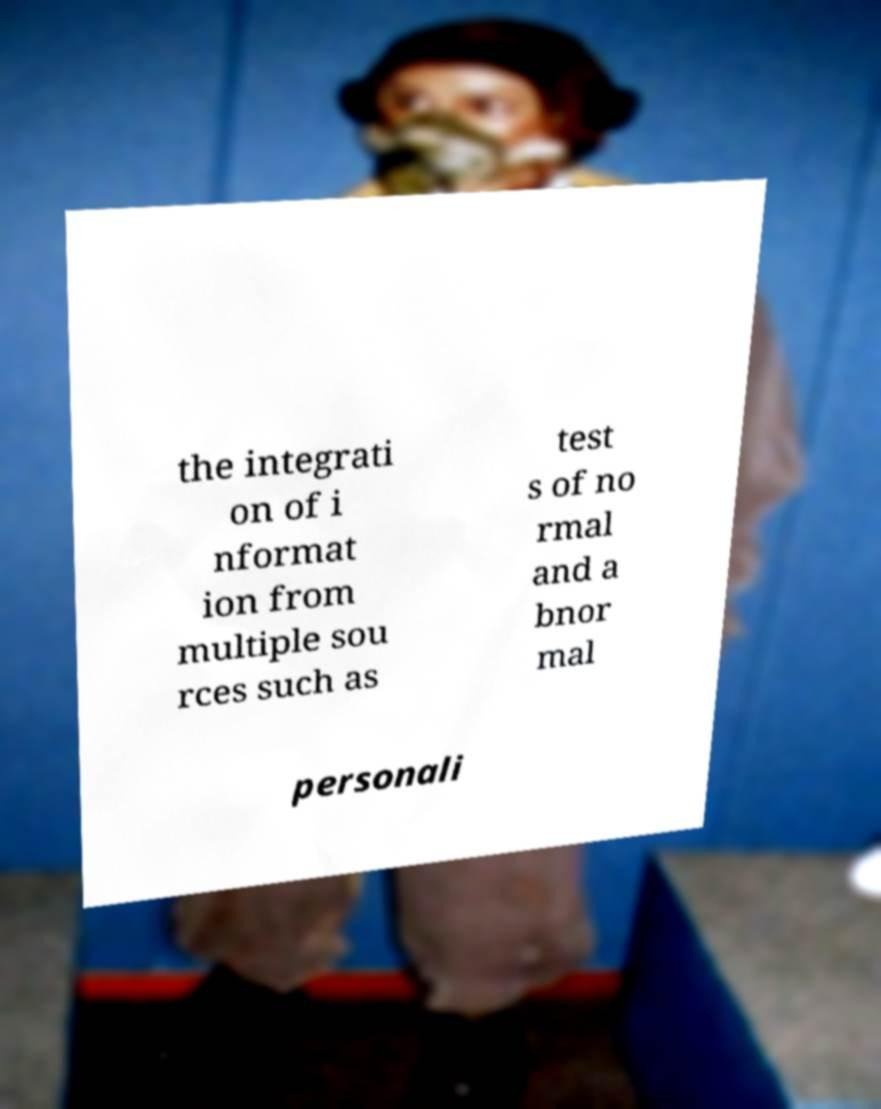Could you extract and type out the text from this image? the integrati on of i nformat ion from multiple sou rces such as test s of no rmal and a bnor mal personali 